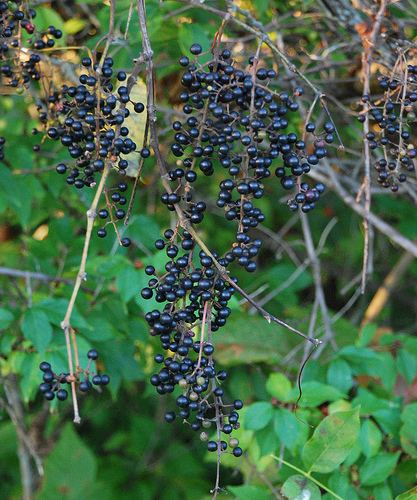<image>
Is the yellow leaf behind the green leaf? Yes. From this viewpoint, the yellow leaf is positioned behind the green leaf, with the green leaf partially or fully occluding the yellow leaf. 